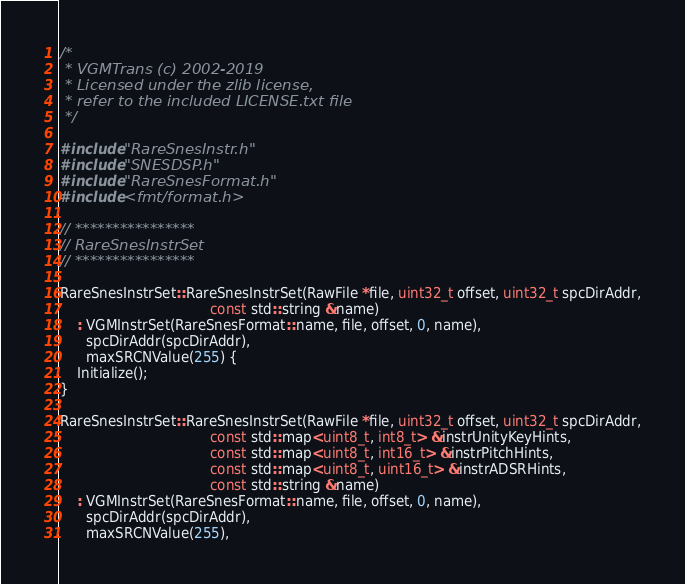<code> <loc_0><loc_0><loc_500><loc_500><_C++_>/*
 * VGMTrans (c) 2002-2019
 * Licensed under the zlib license,
 * refer to the included LICENSE.txt file
 */

#include "RareSnesInstr.h"
#include "SNESDSP.h"
#include "RareSnesFormat.h"
#include <fmt/format.h>

// ****************
// RareSnesInstrSet
// ****************

RareSnesInstrSet::RareSnesInstrSet(RawFile *file, uint32_t offset, uint32_t spcDirAddr,
                                   const std::string &name)
    : VGMInstrSet(RareSnesFormat::name, file, offset, 0, name),
      spcDirAddr(spcDirAddr),
      maxSRCNValue(255) {
    Initialize();
}

RareSnesInstrSet::RareSnesInstrSet(RawFile *file, uint32_t offset, uint32_t spcDirAddr,
                                   const std::map<uint8_t, int8_t> &instrUnityKeyHints,
                                   const std::map<uint8_t, int16_t> &instrPitchHints,
                                   const std::map<uint8_t, uint16_t> &instrADSRHints,
                                   const std::string &name)
    : VGMInstrSet(RareSnesFormat::name, file, offset, 0, name),
      spcDirAddr(spcDirAddr),
      maxSRCNValue(255),</code> 